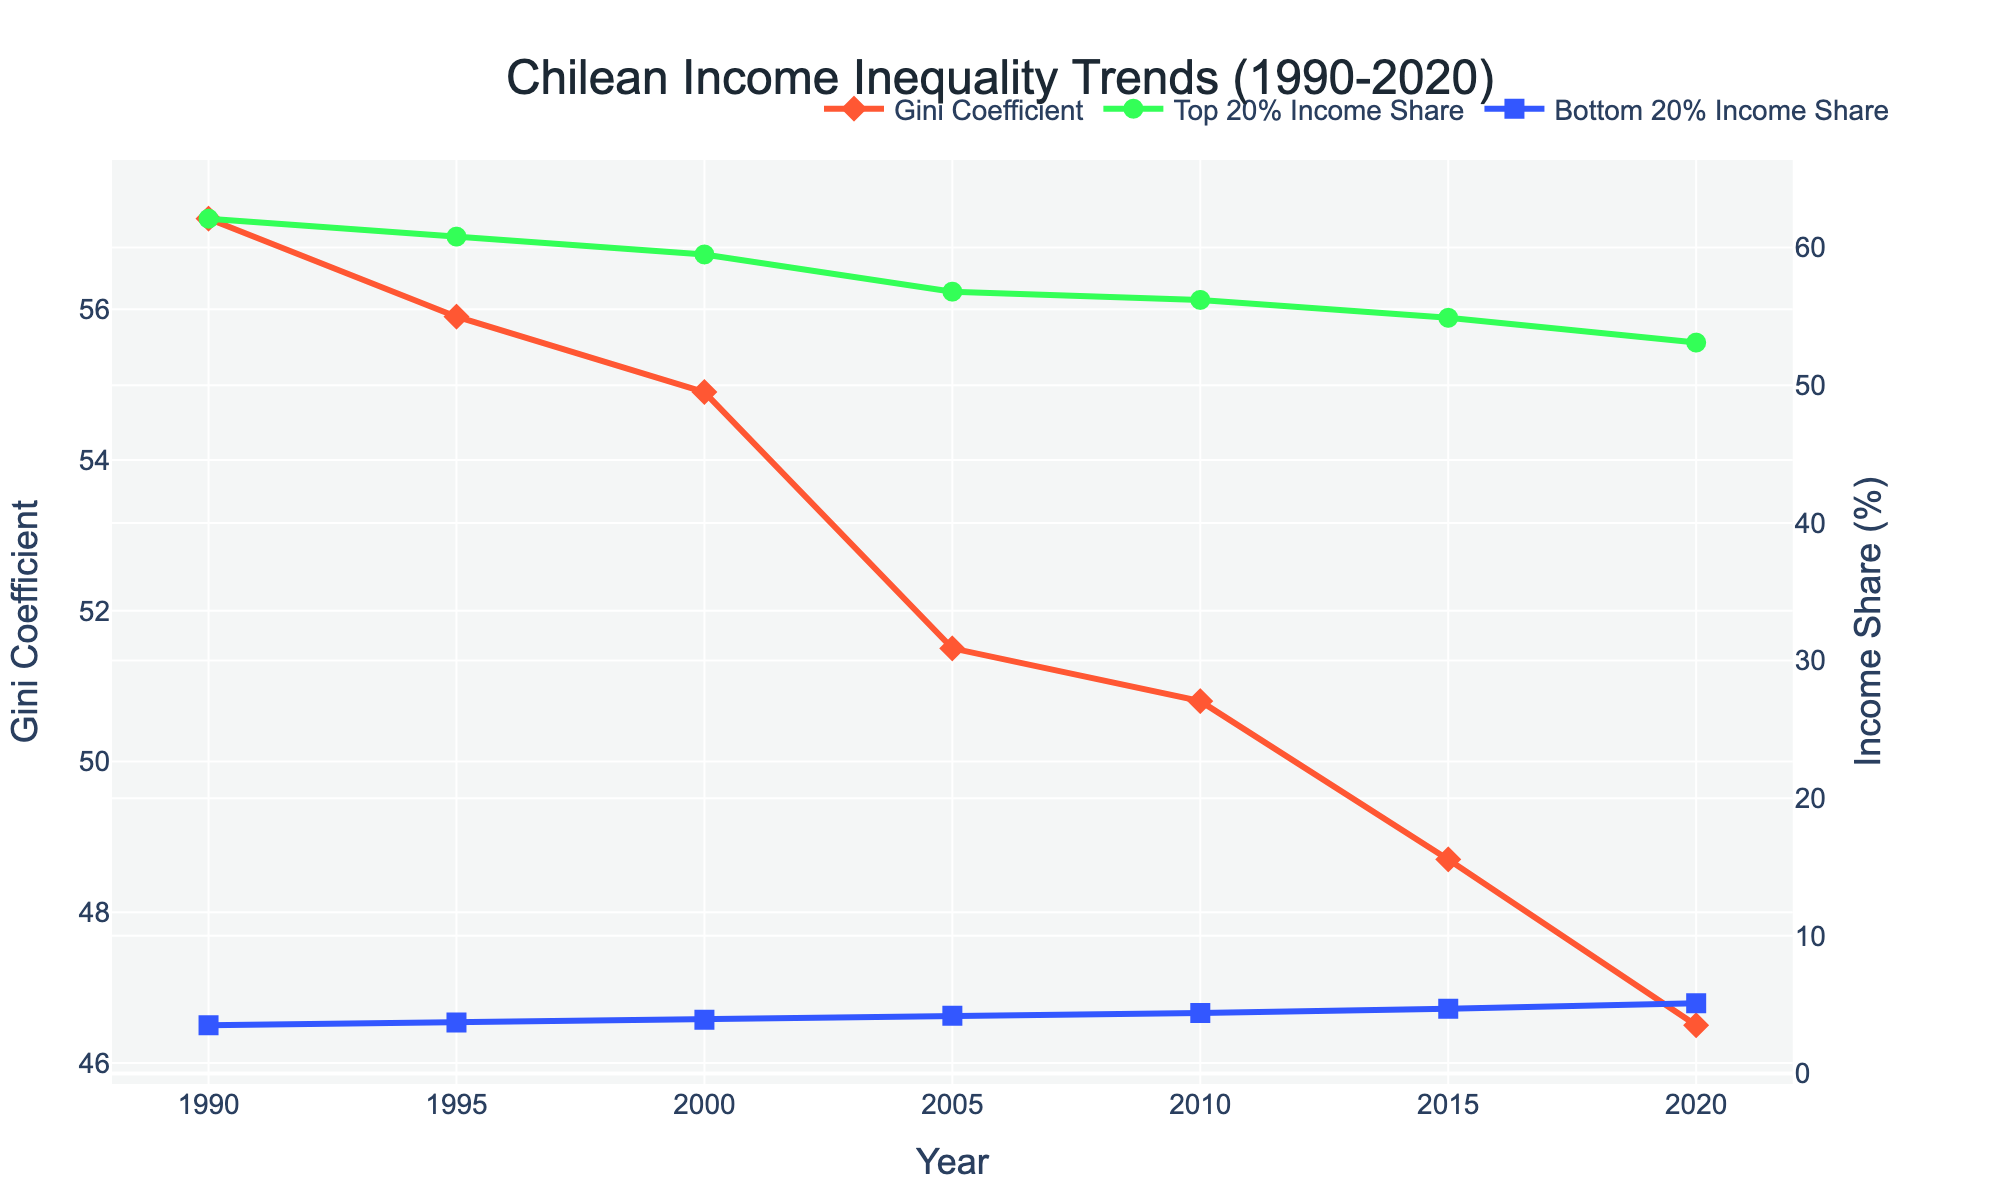What is the Gini Coefficient trend from 1990 to 2020? The Gini Coefficient starts at 57.2 in 1990 and decreases steadily to 46.5 in 2020. This shows a trend of declining income inequality over the 30-year period.
Answer: It decreases How does the income share of the Bottom 20% change from 1990 to 2020? In 1990, the Bottom 20% Income Share is 3.5%. By 2020, it has increased to 5.1%. This indicates an improvement in the income share of the Bottom 20%.
Answer: It increases What is the ratio of the top quintile's income share to the bottom quintile's income share in 2000? The Top 20% Income Share in 2000 is 59.5%, and the Bottom 20% Income Share is 3.9%. To find the ratio, divide 59.5 by 3.9, which is approximately 15.3.
Answer: 15.3 Compare the top 20% income share in 1990 and 2020. Is it higher or lower in 2020? The Top 20% Income Share in 1990 is 62.1%, and in 2020 it is 53.1%. Comparing the two values, the Top 20% Income Share is lower in 2020.
Answer: Lower in 2020 Which year marks the highest Gini Coefficient, and what is its value? By inspecting the Gini Coefficient values across all years, the highest Gini Coefficient is in 1990 with a value of 57.2.
Answer: 1990, 57.2 What is the difference in the Bottom 20% Income Share between 2005 and 2015? The Bottom 20% Income Share in 2005 is 4.2%, and in 2015 it is 4.7%. The difference can be calculated as 4.7% - 4.2% = 0.5%.
Answer: 0.5% How much did the Gini Coefficient decrease from 1990 to 2005? The Gini Coefficient in 1990 is 57.2, and in 2005 it is 51.5. The decrease is found by subtracting 51.5 from 57.2, which equals 5.7.
Answer: 5.7 In which year did the Bottom 20% Income Share experience the highest growth compared to the previous data point? Comparing each pair of consecutive years, the largest increase in Bottom 20% Income Share is between 2000 (3.9%) and 2005 (4.2%), an increase of 0.3%.
Answer: 2005 What are the colors used to represent the Gini Coefficient, Top 20% Income Share, and Bottom 20% Income Share in the plot? The Gini Coefficient is represented in red, the Top 20% Income Share in green, and the Bottom 20% Income Share in blue.
Answer: Red, green, blue What is the difference between the Top 20% and Bottom 20% Income Shares in 1995? The Top 20% Income Share in 1995 is 60.8%, and the Bottom 20% Income Share is 3.7%. Subtracting 3.7 from 60.8 gives a difference of 57.1%.
Answer: 57.1% 